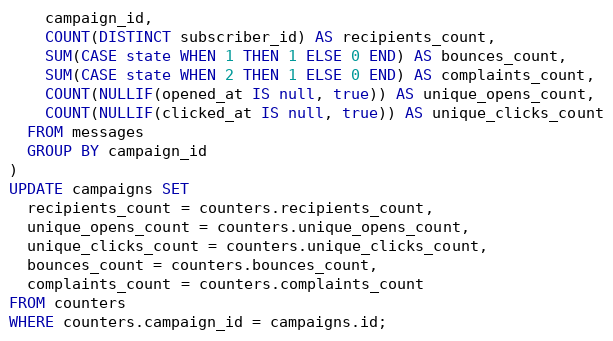<code> <loc_0><loc_0><loc_500><loc_500><_SQL_>    campaign_id,
    COUNT(DISTINCT subscriber_id) AS recipients_count,
    SUM(CASE state WHEN 1 THEN 1 ELSE 0 END) AS bounces_count,
    SUM(CASE state WHEN 2 THEN 1 ELSE 0 END) AS complaints_count,
    COUNT(NULLIF(opened_at IS null, true)) AS unique_opens_count,
    COUNT(NULLIF(clicked_at IS null, true)) AS unique_clicks_count
  FROM messages
  GROUP BY campaign_id
)
UPDATE campaigns SET
  recipients_count = counters.recipients_count,
  unique_opens_count = counters.unique_opens_count,
  unique_clicks_count = counters.unique_clicks_count,
  bounces_count = counters.bounces_count,
  complaints_count = counters.complaints_count
FROM counters
WHERE counters.campaign_id = campaigns.id;
</code> 